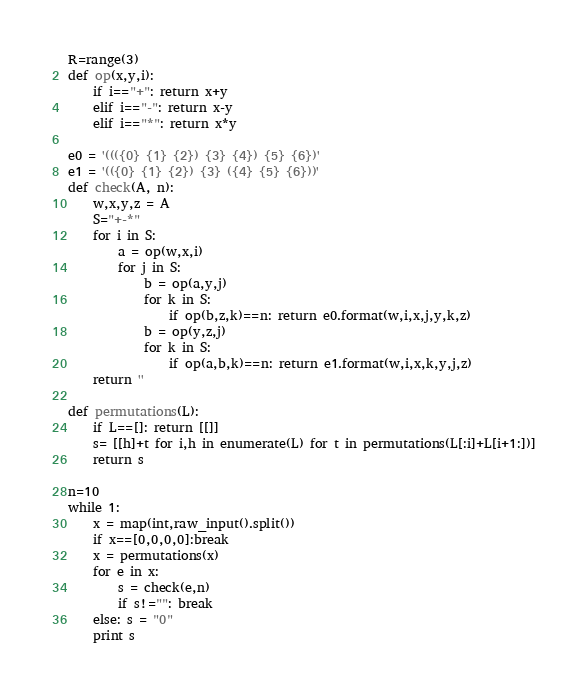Convert code to text. <code><loc_0><loc_0><loc_500><loc_500><_Python_>R=range(3)
def op(x,y,i):
    if i=="+": return x+y
    elif i=="-": return x-y
    elif i=="*": return x*y

e0 = '((({0} {1} {2}) {3} {4}) {5} {6})'
e1 = '(({0} {1} {2}) {3} ({4} {5} {6}))'
def check(A, n):
    w,x,y,z = A
    S="+-*"
    for i in S:
        a = op(w,x,i)
        for j in S:
            b = op(a,y,j)
            for k in S:
                if op(b,z,k)==n: return e0.format(w,i,x,j,y,k,z)
            b = op(y,z,j)
            for k in S:
                if op(a,b,k)==n: return e1.format(w,i,x,k,y,j,z)
    return ''

def permutations(L):
    if L==[]: return [[]]
    s= [[h]+t for i,h in enumerate(L) for t in permutations(L[:i]+L[i+1:])]
    return s

n=10
while 1:
    x = map(int,raw_input().split())
    if x==[0,0,0,0]:break
    x = permutations(x)
    for e in x:
        s = check(e,n)
        if s!="": break
    else: s = "0"
    print s</code> 